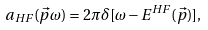<formula> <loc_0><loc_0><loc_500><loc_500>a _ { H F } ( \vec { p } \omega ) = 2 \pi \delta [ \omega - E ^ { H F } ( \vec { p } ) ] ,</formula> 